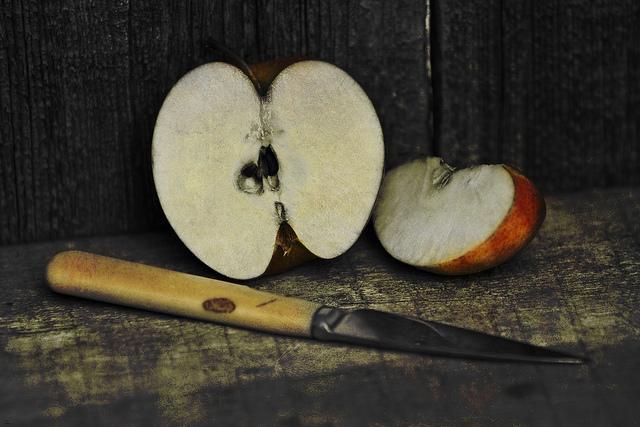What is the knife being used for?
Be succinct. Cut apple. Are all the pieces of the apple pictured?
Answer briefly. No. Is there an apple?
Concise answer only. Yes. 